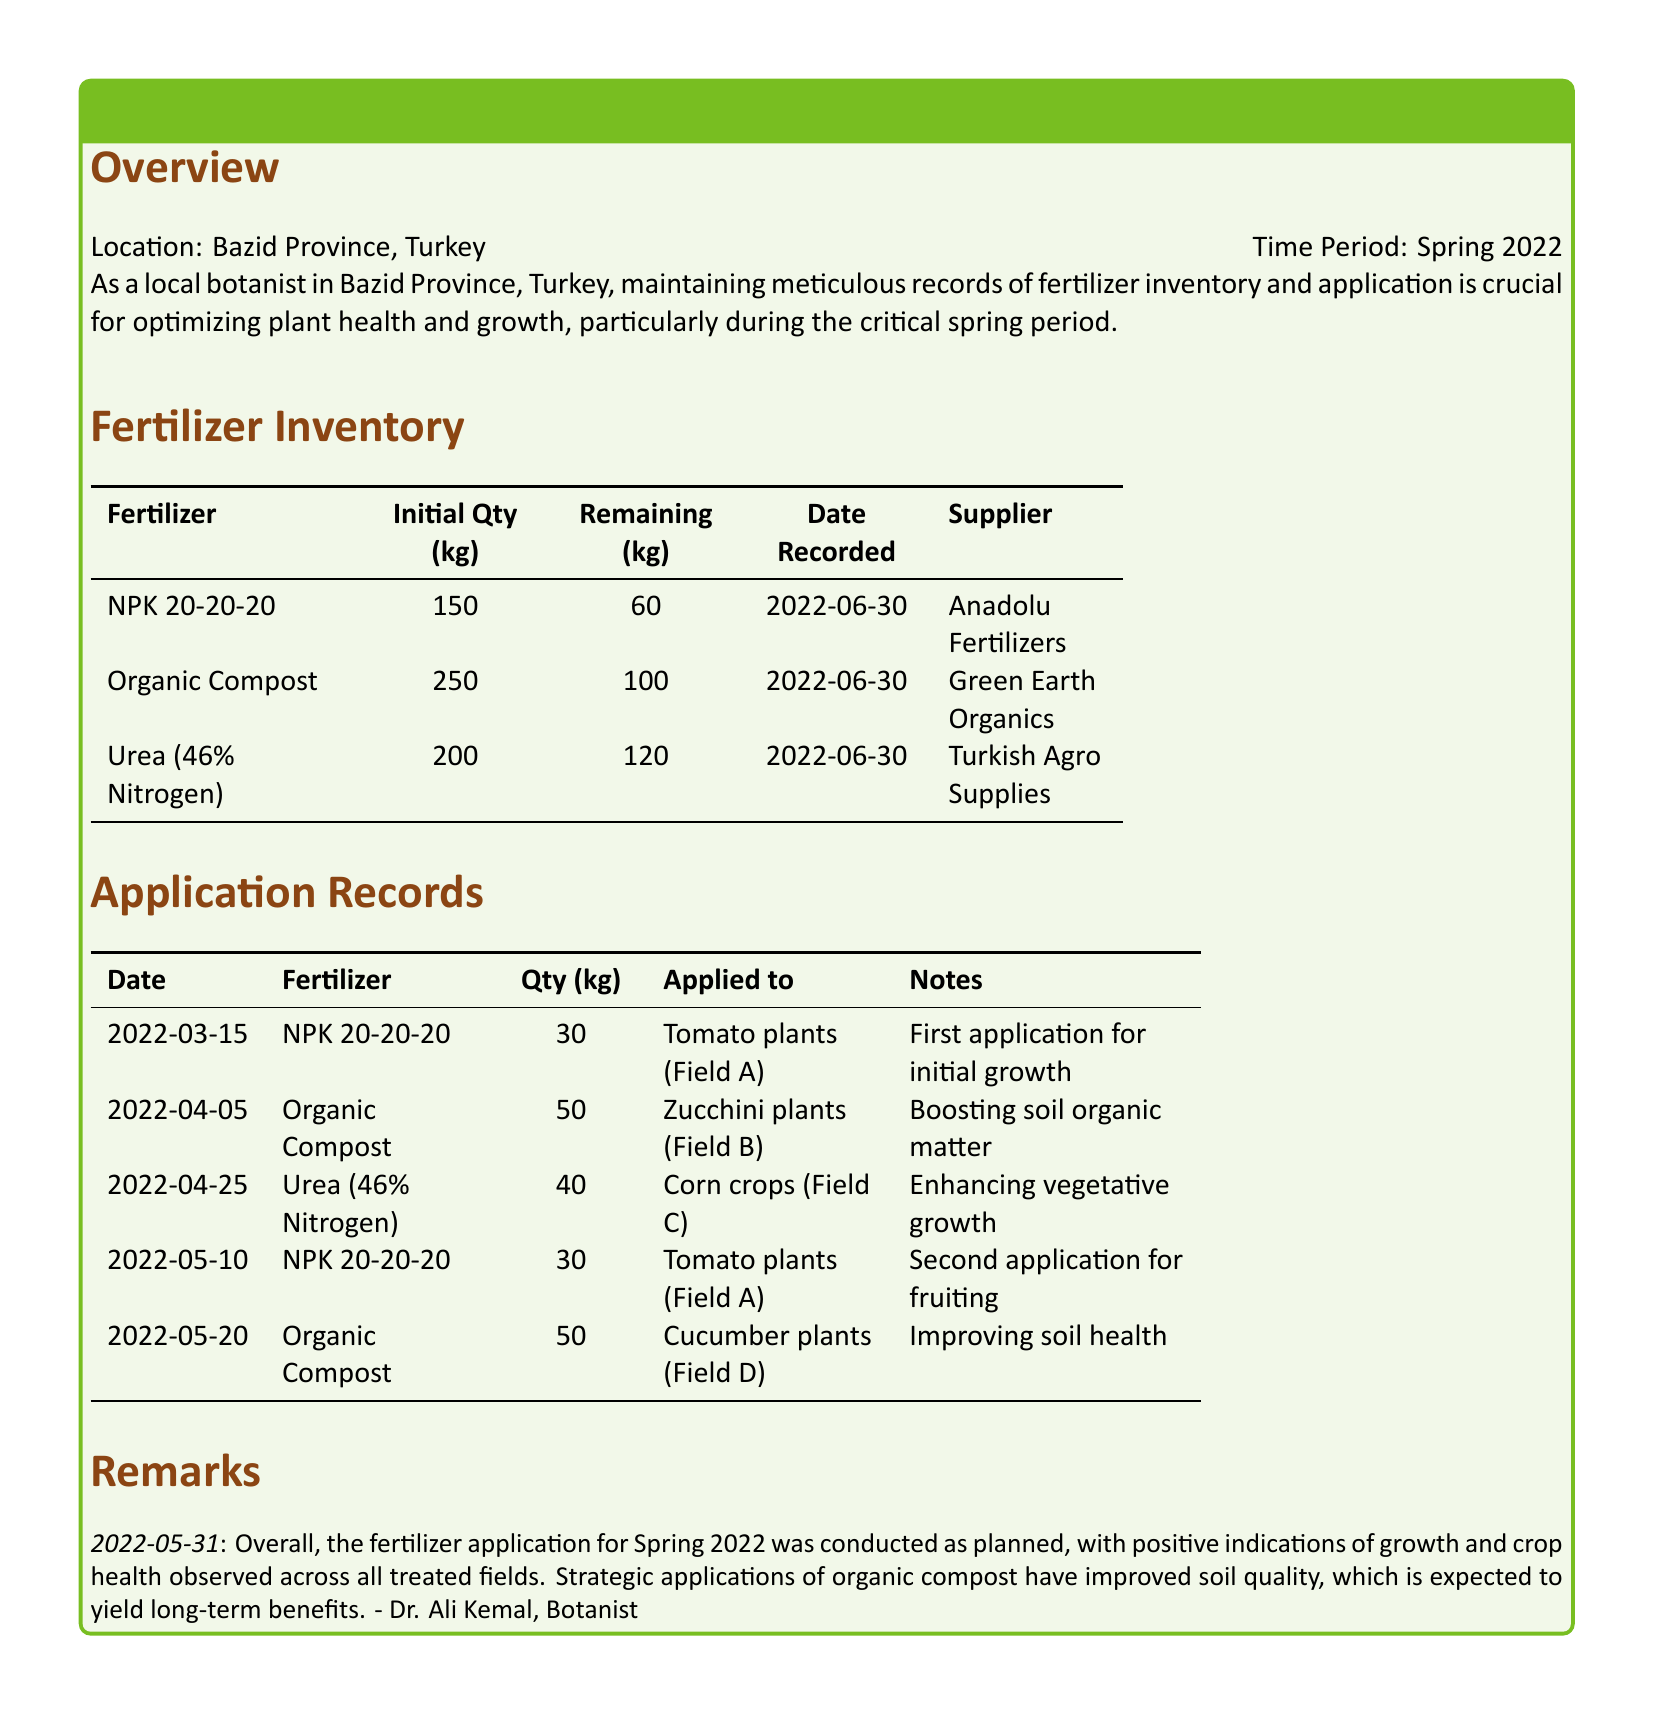What is the initial quantity of NPK 20-20-20? The initial quantity of NPK 20-20-20 is stated in the inventory section, which shows it as 150 kg.
Answer: 150 kg Who supplied Organic Compost? The supplier for Organic Compost is identified in the inventory section, specifically listed as Green Earth Organics.
Answer: Green Earth Organics When was Urea applied? The application date for Urea (46% Nitrogen) can be found in the application records, which lists it as applied on April 25, 2022.
Answer: April 25, 2022 What quantity of fertilizer was applied to tomato plants on March 15? The application records indicate that 30 kg of NPK 20-20-20 was applied to the tomato plants on March 15, 2022.
Answer: 30 kg What is noted about the overall fertilizer application? The remarks section summarizes the effectiveness of the fertilizer application, noting positive growth and crop health outcomes across treated fields.
Answer: Positive growth How many kg of Organic Compost were applied to cucumber plants? The application records detail that 50 kg of Organic Compost was applied to cucumber plants on May 20, 2022.
Answer: 50 kg Which fertilizer was used to enhance vegetative growth? The application records specify that Urea (46% Nitrogen) was applied to enhance vegetative growth for corn crops on April 25, 2022.
Answer: Urea (46% Nitrogen) What is the remaining quantity of Urea? The remaining quantity of Urea, as per the inventory, is provided as 120 kg.
Answer: 120 kg How many total applications of NPK 20-20-20 were recorded? The application records reveal two entries where NPK 20-20-20 was applied to tomato plants, indicating two total applications.
Answer: 2 